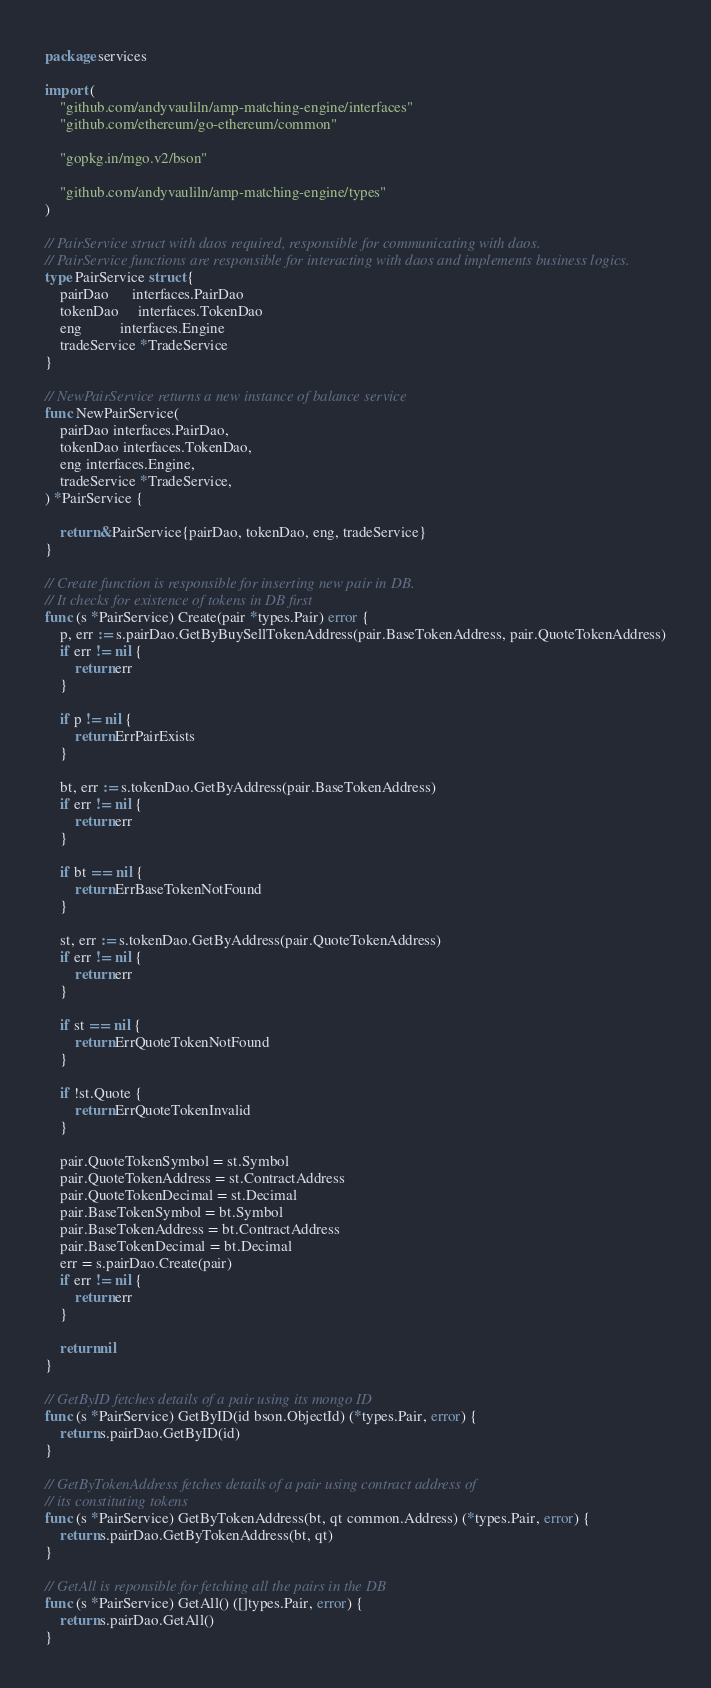Convert code to text. <code><loc_0><loc_0><loc_500><loc_500><_Go_>package services

import (
	"github.com/andyvauliln/amp-matching-engine/interfaces"
	"github.com/ethereum/go-ethereum/common"

	"gopkg.in/mgo.v2/bson"

	"github.com/andyvauliln/amp-matching-engine/types"
)

// PairService struct with daos required, responsible for communicating with daos.
// PairService functions are responsible for interacting with daos and implements business logics.
type PairService struct {
	pairDao      interfaces.PairDao
	tokenDao     interfaces.TokenDao
	eng          interfaces.Engine
	tradeService *TradeService
}

// NewPairService returns a new instance of balance service
func NewPairService(
	pairDao interfaces.PairDao,
	tokenDao interfaces.TokenDao,
	eng interfaces.Engine,
	tradeService *TradeService,
) *PairService {

	return &PairService{pairDao, tokenDao, eng, tradeService}
}

// Create function is responsible for inserting new pair in DB.
// It checks for existence of tokens in DB first
func (s *PairService) Create(pair *types.Pair) error {
	p, err := s.pairDao.GetByBuySellTokenAddress(pair.BaseTokenAddress, pair.QuoteTokenAddress)
	if err != nil {
		return err
	}

	if p != nil {
		return ErrPairExists
	}

	bt, err := s.tokenDao.GetByAddress(pair.BaseTokenAddress)
	if err != nil {
		return err
	}

	if bt == nil {
		return ErrBaseTokenNotFound
	}

	st, err := s.tokenDao.GetByAddress(pair.QuoteTokenAddress)
	if err != nil {
		return err
	}

	if st == nil {
		return ErrQuoteTokenNotFound
	}

	if !st.Quote {
		return ErrQuoteTokenInvalid
	}

	pair.QuoteTokenSymbol = st.Symbol
	pair.QuoteTokenAddress = st.ContractAddress
	pair.QuoteTokenDecimal = st.Decimal
	pair.BaseTokenSymbol = bt.Symbol
	pair.BaseTokenAddress = bt.ContractAddress
	pair.BaseTokenDecimal = bt.Decimal
	err = s.pairDao.Create(pair)
	if err != nil {
		return err
	}

	return nil
}

// GetByID fetches details of a pair using its mongo ID
func (s *PairService) GetByID(id bson.ObjectId) (*types.Pair, error) {
	return s.pairDao.GetByID(id)
}

// GetByTokenAddress fetches details of a pair using contract address of
// its constituting tokens
func (s *PairService) GetByTokenAddress(bt, qt common.Address) (*types.Pair, error) {
	return s.pairDao.GetByTokenAddress(bt, qt)
}

// GetAll is reponsible for fetching all the pairs in the DB
func (s *PairService) GetAll() ([]types.Pair, error) {
	return s.pairDao.GetAll()
}
</code> 